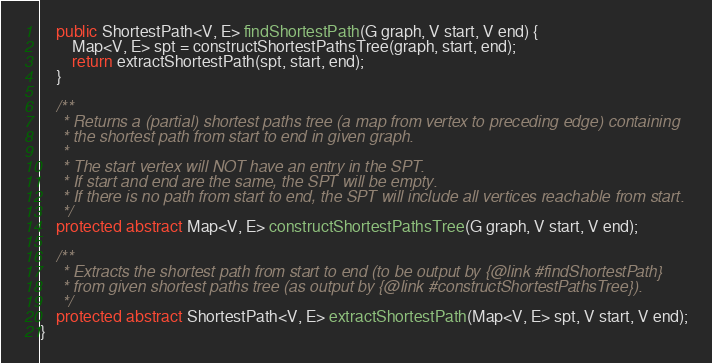<code> <loc_0><loc_0><loc_500><loc_500><_Java_>    public ShortestPath<V, E> findShortestPath(G graph, V start, V end) {
        Map<V, E> spt = constructShortestPathsTree(graph, start, end);
        return extractShortestPath(spt, start, end);
    }

    /**
     * Returns a (partial) shortest paths tree (a map from vertex to preceding edge) containing
     * the shortest path from start to end in given graph.
     *
     * The start vertex will NOT have an entry in the SPT.
     * If start and end are the same, the SPT will be empty.
     * If there is no path from start to end, the SPT will include all vertices reachable from start.
     */
    protected abstract Map<V, E> constructShortestPathsTree(G graph, V start, V end);

    /**
     * Extracts the shortest path from start to end (to be output by {@link #findShortestPath}
     * from given shortest paths tree (as output by {@link #constructShortestPathsTree}).
     */
    protected abstract ShortestPath<V, E> extractShortestPath(Map<V, E> spt, V start, V end);
}
</code> 